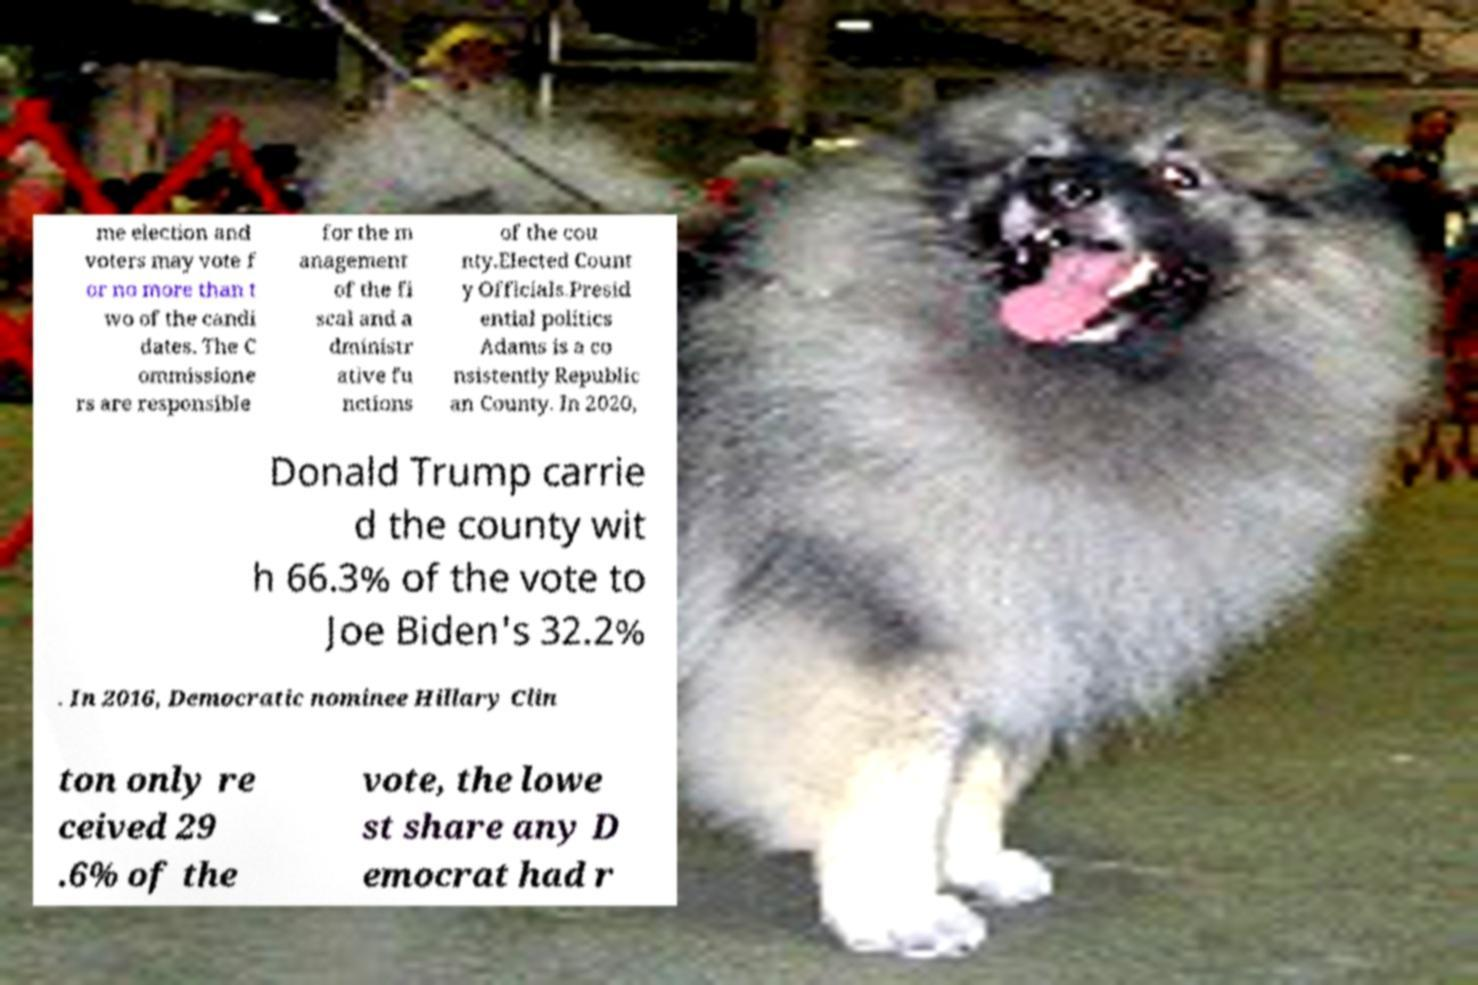Could you extract and type out the text from this image? me election and voters may vote f or no more than t wo of the candi dates. The C ommissione rs are responsible for the m anagement of the fi scal and a dministr ative fu nctions of the cou nty.Elected Count y Officials.Presid ential politics Adams is a co nsistently Republic an County. In 2020, Donald Trump carrie d the county wit h 66.3% of the vote to Joe Biden's 32.2% . In 2016, Democratic nominee Hillary Clin ton only re ceived 29 .6% of the vote, the lowe st share any D emocrat had r 